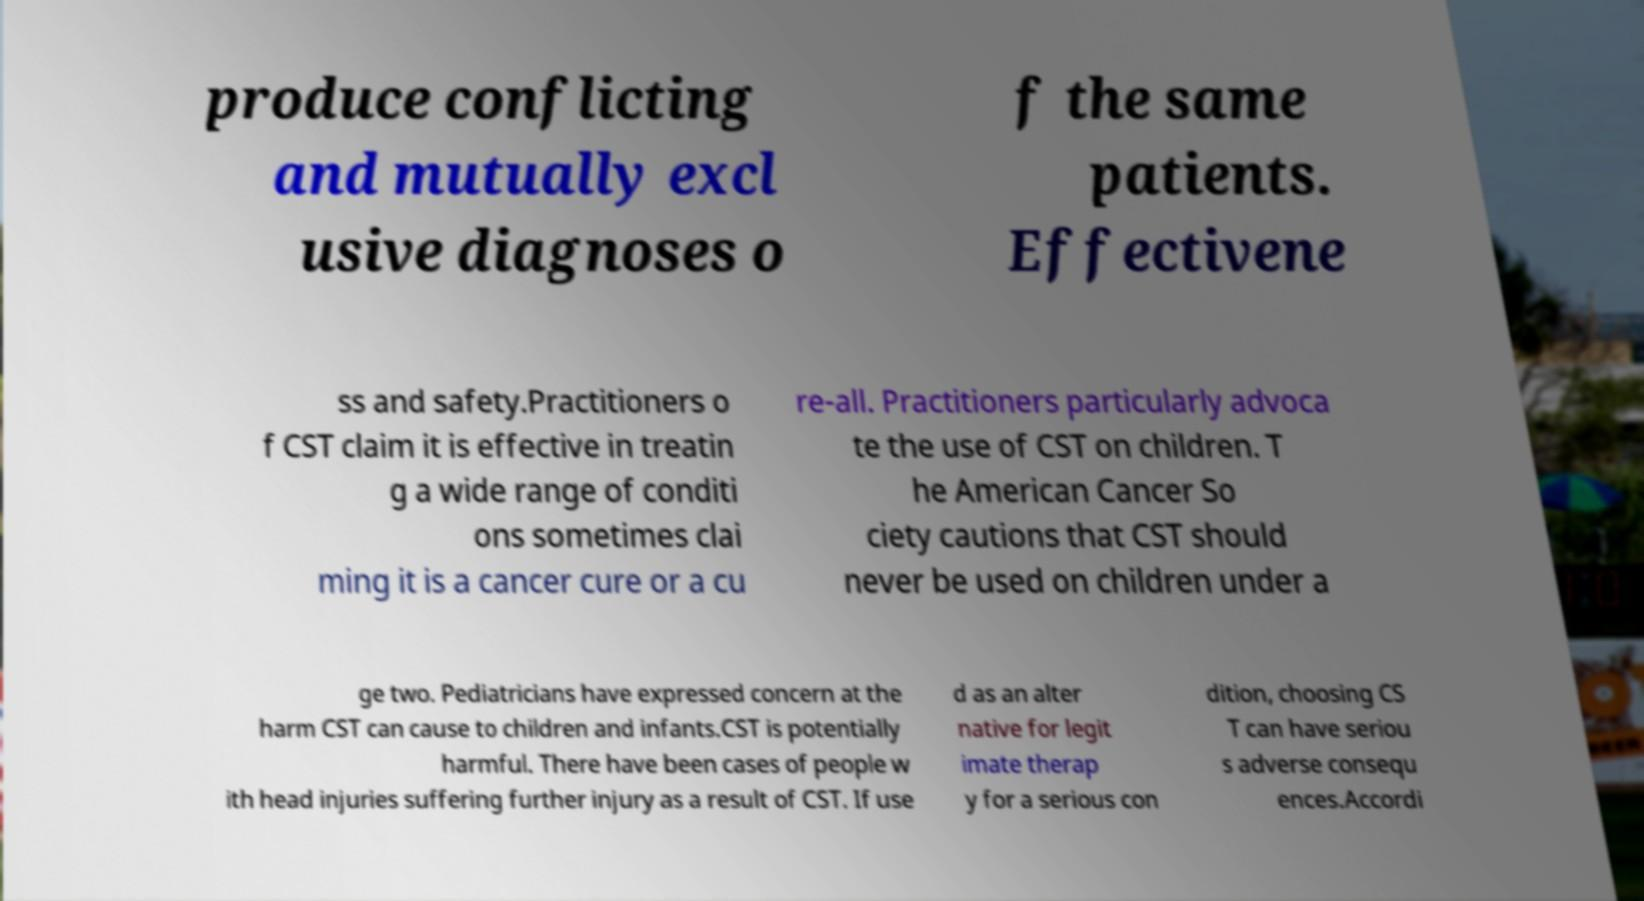What messages or text are displayed in this image? I need them in a readable, typed format. produce conflicting and mutually excl usive diagnoses o f the same patients. Effectivene ss and safety.Practitioners o f CST claim it is effective in treatin g a wide range of conditi ons sometimes clai ming it is a cancer cure or a cu re-all. Practitioners particularly advoca te the use of CST on children. T he American Cancer So ciety cautions that CST should never be used on children under a ge two. Pediatricians have expressed concern at the harm CST can cause to children and infants.CST is potentially harmful. There have been cases of people w ith head injuries suffering further injury as a result of CST. If use d as an alter native for legit imate therap y for a serious con dition, choosing CS T can have seriou s adverse consequ ences.Accordi 